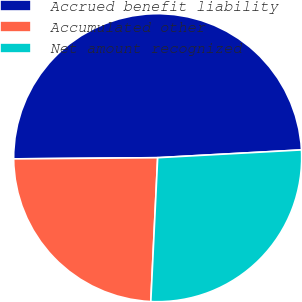Convert chart. <chart><loc_0><loc_0><loc_500><loc_500><pie_chart><fcel>Accrued benefit liability<fcel>Accumulated other<fcel>Net amount recognized<nl><fcel>49.27%<fcel>24.11%<fcel>26.62%<nl></chart> 